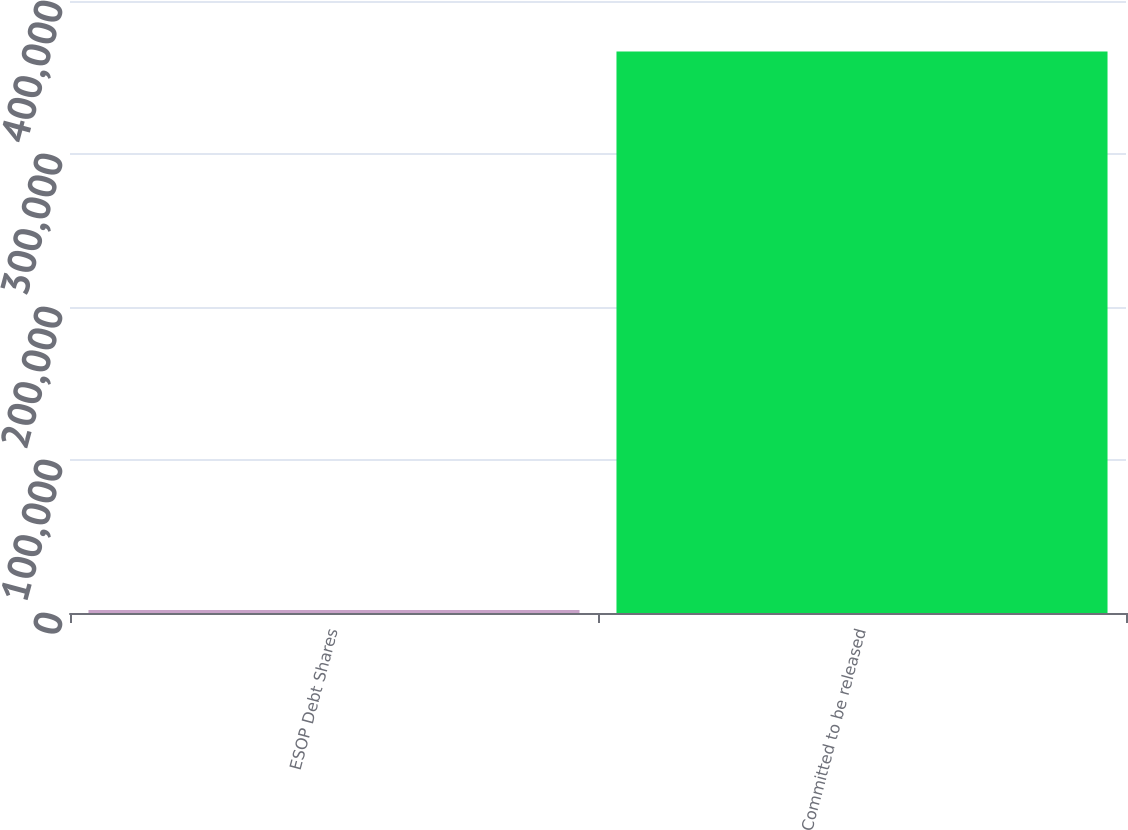Convert chart. <chart><loc_0><loc_0><loc_500><loc_500><bar_chart><fcel>ESOP Debt Shares<fcel>Committed to be released<nl><fcel>2005<fcel>366969<nl></chart> 